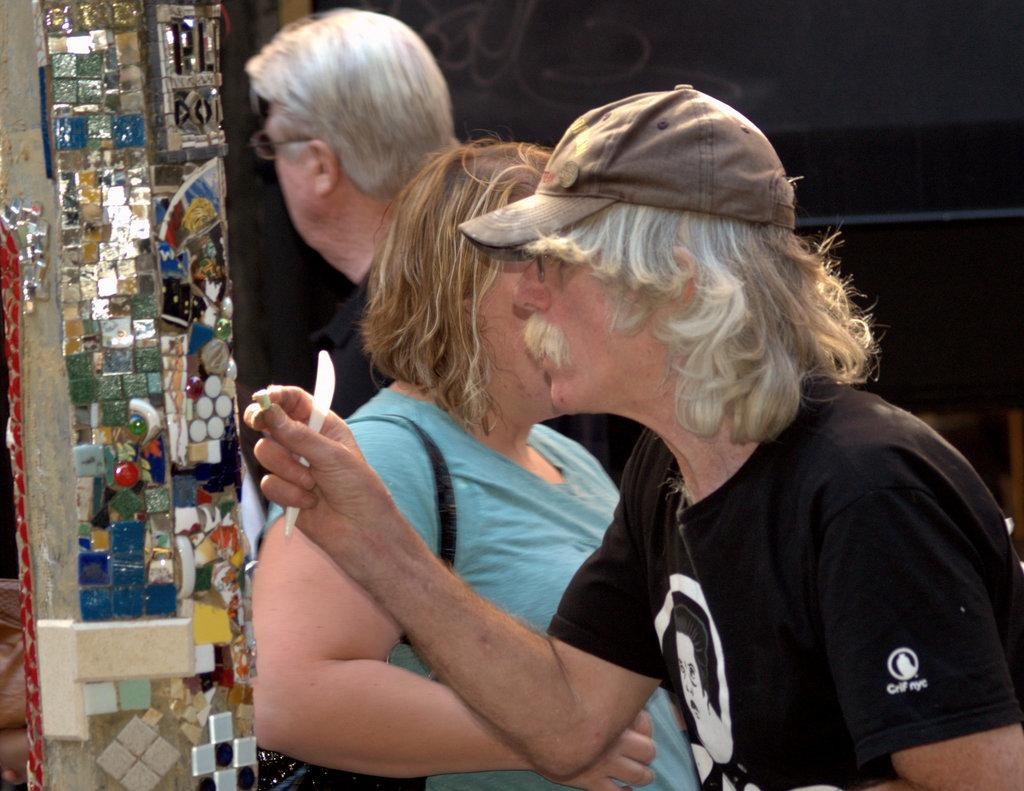What is happening in the image? There are people standing in the image. Can you describe what the man is holding in his hand? There is a man holding something in his hand, but the specific object cannot be determined from the image. What can be seen on the pillar in the image? There are stones on a pillar in the image. How would you describe the lighting in the image? The background of the image is dark. What type of fuel is stored on the shelf in the image? There is no shelf present in the image, and therefore no fuel can be observed. 